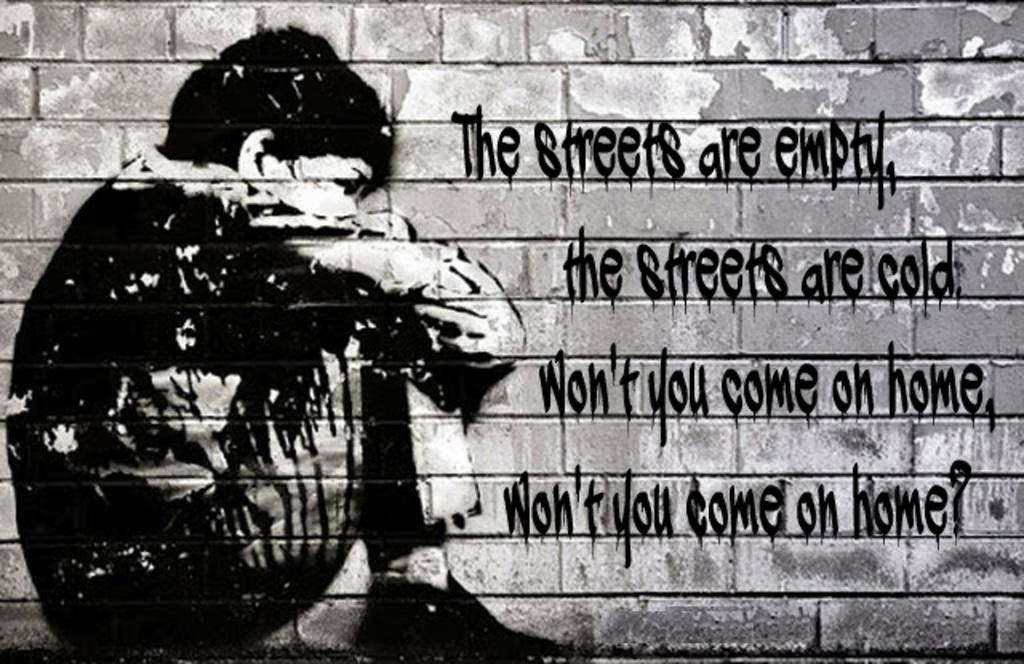What is depicted on the wall in the image? There is a painting on a wall in the image. What type of smell can be detected from the painting in the image? There is no information about the smell of the painting in the image, as it is a visual medium. 